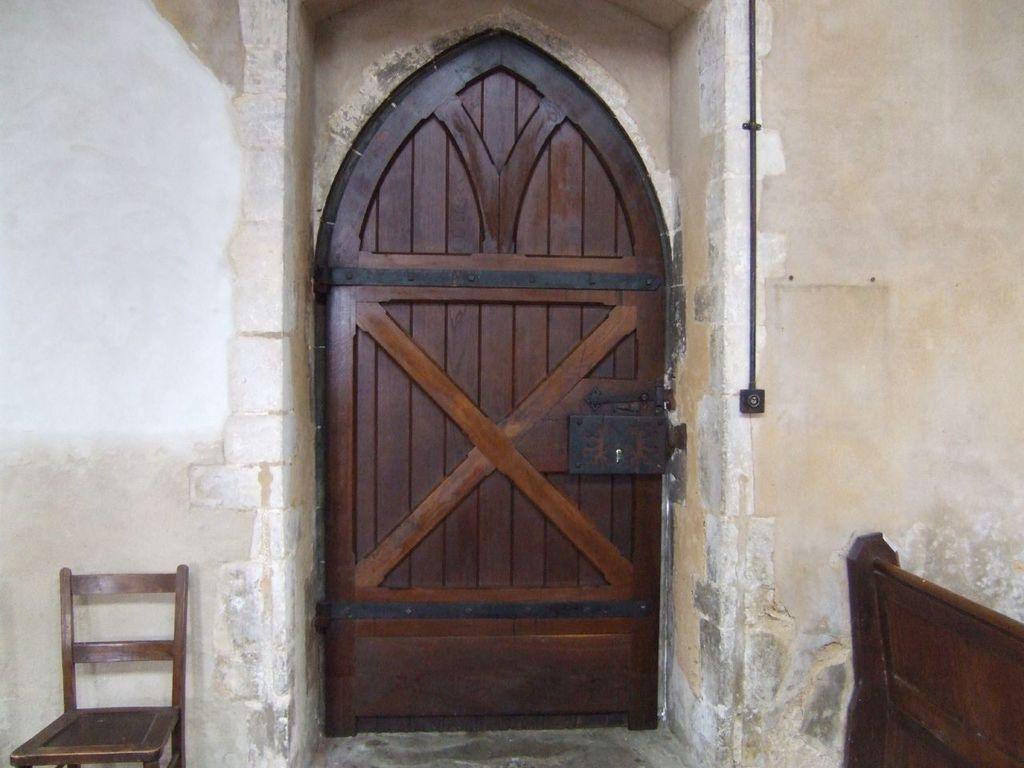What is located at the front of the image? There is a door in the front of the image. What type of seating is on the left side of the image? There is an empty chair on the left side of the image. What type of seating is on the right side of the image? There is an empty bench on the right side of the image. What is in the center of the image? There is a wall in the center of the image. What is the name of the daughter who is sitting on the bench in the image? There is no daughter present in the image; it only shows an empty bench. How many chickens can be seen in the image? There are no chickens present in the image. 